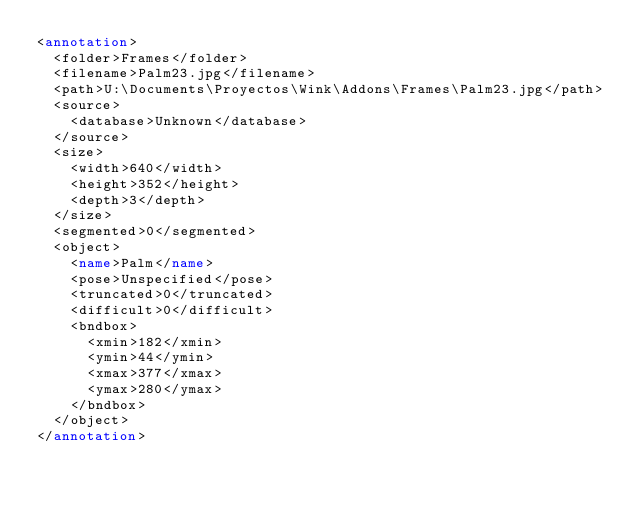<code> <loc_0><loc_0><loc_500><loc_500><_XML_><annotation>
	<folder>Frames</folder>
	<filename>Palm23.jpg</filename>
	<path>U:\Documents\Proyectos\Wink\Addons\Frames\Palm23.jpg</path>
	<source>
		<database>Unknown</database>
	</source>
	<size>
		<width>640</width>
		<height>352</height>
		<depth>3</depth>
	</size>
	<segmented>0</segmented>
	<object>
		<name>Palm</name>
		<pose>Unspecified</pose>
		<truncated>0</truncated>
		<difficult>0</difficult>
		<bndbox>
			<xmin>182</xmin>
			<ymin>44</ymin>
			<xmax>377</xmax>
			<ymax>280</ymax>
		</bndbox>
	</object>
</annotation>
</code> 